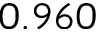<formula> <loc_0><loc_0><loc_500><loc_500>0 . 9 6 0</formula> 